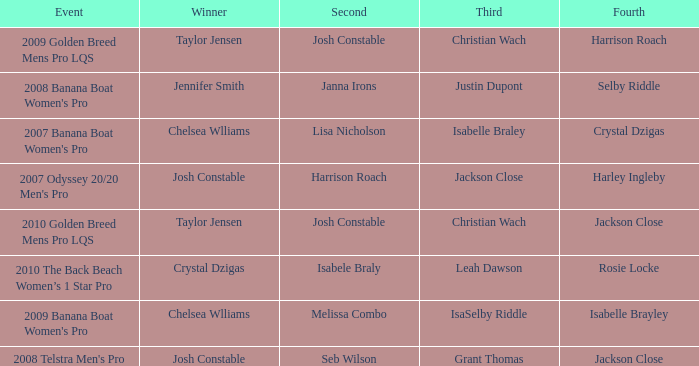Who was Fourth in the 2008 Telstra Men's Pro Event? Jackson Close. 